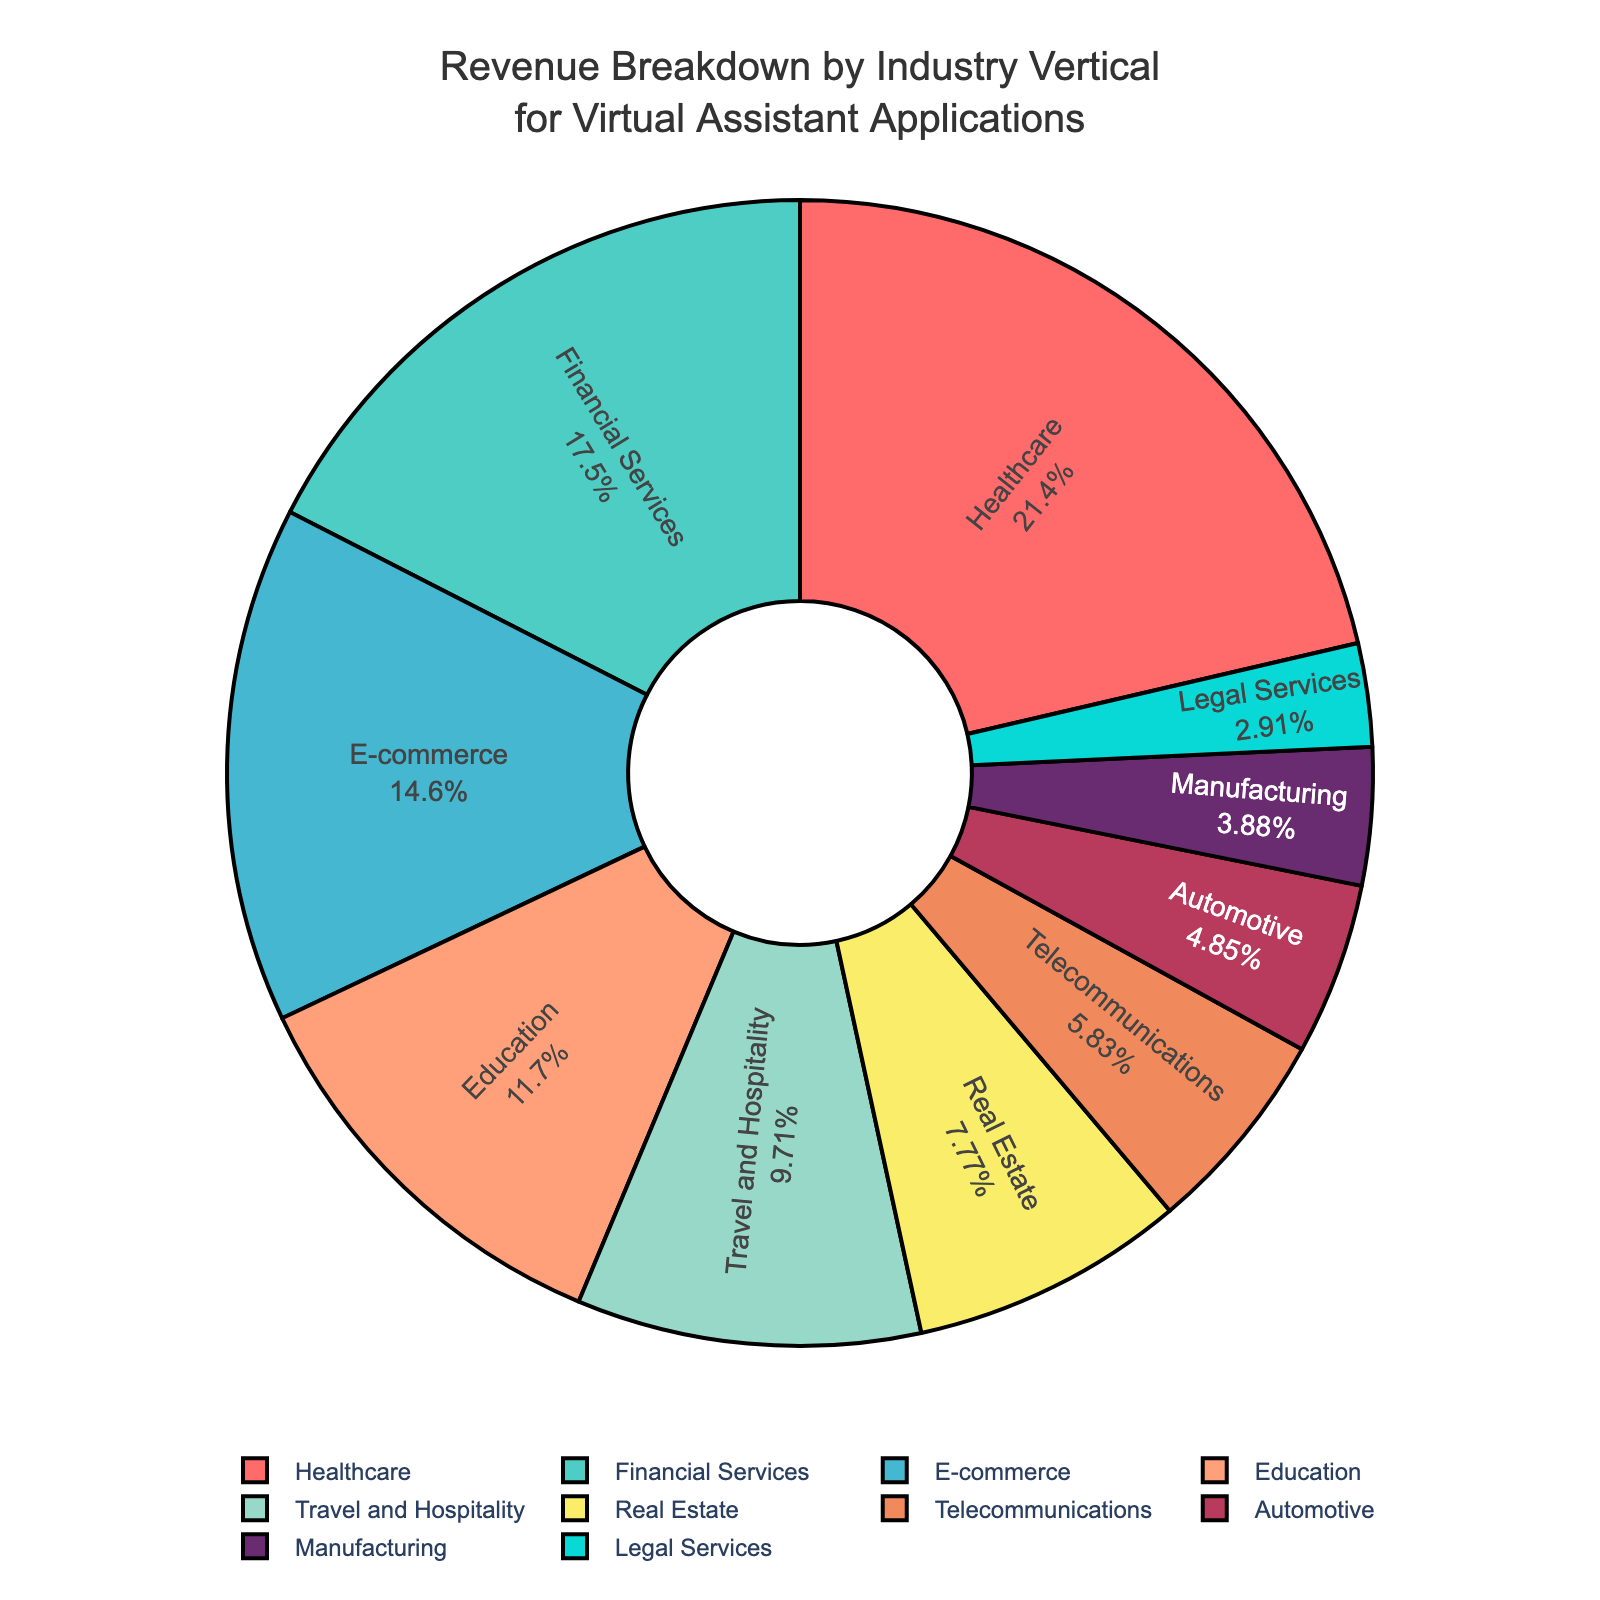What's the industry vertical with the highest revenue percentage? The figure shows a pie chart with different industry verticals labeled and their respective revenue percentages. The Healthcare sector has the largest segment, which is directly labeled as 22%.
Answer: Healthcare Which industry verticals together account for exactly 40% of the revenue? By looking at the pie chart, Financial Services (18%) and E-commerce (15%) together amount to 33%. Adding the next highest, Education (12%), exceeds 40%. However, combining Financial Services (18%) and Travel and Hospitality (10%) results in 28%. To reach exactly 40%, we should instead combine E-commerce (15%), Education (12%), and Telecommunications (6%) which give us 33%. Adding the smallest, Legal Services (3%) totals 36%, still missing the target by 4%. Therefore, a precise 40% split isn't achievable from available segments.
Answer: Not possible What's the combined revenue percentage of E-commerce, Travel and Hospitality, and Legal Services? Sum the revenue percentages from E-commerce, Travel and Hospitality, and Legal Services. This calculation is 15% (E-commerce) + 10% (Travel and Hospitality) + 3% (Legal Services) = 28%.
Answer: 28% Is the revenue percentage of Education higher or lower than that of Real Estate? Compare the revenue percentages of the Education sector (12%) and the Real Estate sector (8%) as shown on the pie chart. Education (12%) is higher than Real Estate (8%).
Answer: Higher Which sector(s) combined are equal to the revenue percentage of the Healthcare sector? The Healthcare sector is 22%. By examining other sectors: Financial Services (18%) + Legal Services (3%) = 21%, very close to 22%. Adding Manufacturing (4%) results in exceeding 22%. Therefore, no exact match is available with other sectors remaining.
Answer: Not possible What is the visual characteristic used to distinguish the Healthcare sector in the pie chart? The pie chart uses color coding and the Healthcare sector is represented by the largest segment in red color.
Answer: Red segment with the largest area Which sector has a revenue percentage closest to that of Telecommunications? Telecommunications has a revenue percentage of 6%. Comparing it to other sectors, Legal Services at 3% and Automotive at 5% are the nearest. Automotive (5%) is closest to Telecommunications (6%) in the pie chart.
Answer: Automotive What percentage of total revenue is contributed by the sectors under 10%? Identify the sectors under 10%: Real Estate (8%), Telecommunications (6%), Automotive (5%), Manufacturing (4%), and Legal Services (3%). Sum these percentages: 8% + 6% + 5% + 4% + 3% = 26%.
Answer: 26% 